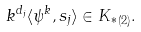Convert formula to latex. <formula><loc_0><loc_0><loc_500><loc_500>k ^ { d _ { j } } \langle \psi ^ { k } , s _ { j } \rangle \in { K _ { * } } _ { ( 2 ) } .</formula> 